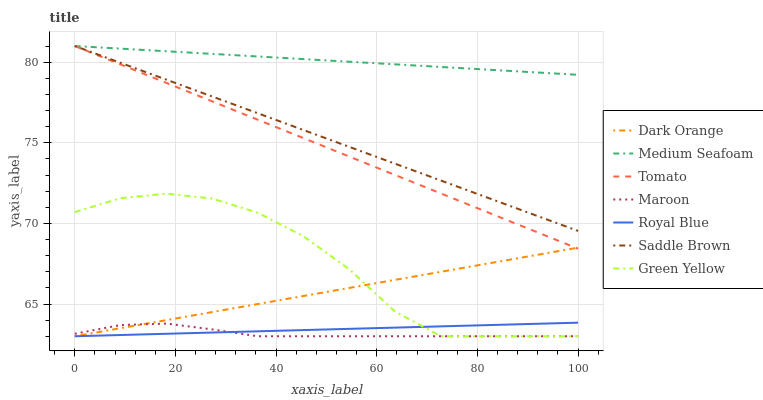Does Maroon have the minimum area under the curve?
Answer yes or no. Yes. Does Medium Seafoam have the maximum area under the curve?
Answer yes or no. Yes. Does Dark Orange have the minimum area under the curve?
Answer yes or no. No. Does Dark Orange have the maximum area under the curve?
Answer yes or no. No. Is Dark Orange the smoothest?
Answer yes or no. Yes. Is Green Yellow the roughest?
Answer yes or no. Yes. Is Maroon the smoothest?
Answer yes or no. No. Is Maroon the roughest?
Answer yes or no. No. Does Dark Orange have the lowest value?
Answer yes or no. Yes. Does Medium Seafoam have the lowest value?
Answer yes or no. No. Does Saddle Brown have the highest value?
Answer yes or no. Yes. Does Dark Orange have the highest value?
Answer yes or no. No. Is Dark Orange less than Saddle Brown?
Answer yes or no. Yes. Is Medium Seafoam greater than Green Yellow?
Answer yes or no. Yes. Does Green Yellow intersect Royal Blue?
Answer yes or no. Yes. Is Green Yellow less than Royal Blue?
Answer yes or no. No. Is Green Yellow greater than Royal Blue?
Answer yes or no. No. Does Dark Orange intersect Saddle Brown?
Answer yes or no. No. 